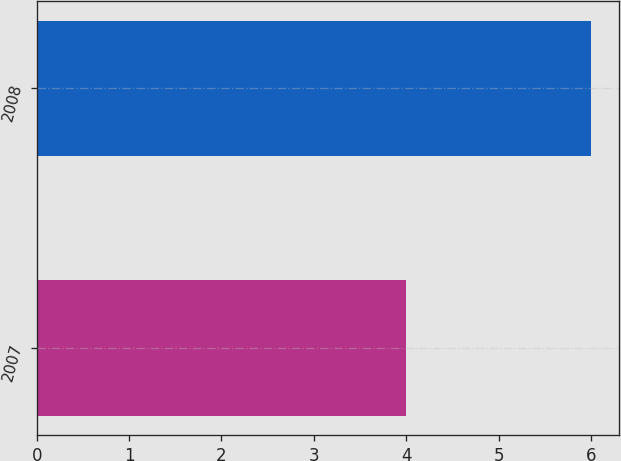<chart> <loc_0><loc_0><loc_500><loc_500><bar_chart><fcel>2007<fcel>2008<nl><fcel>4<fcel>6<nl></chart> 